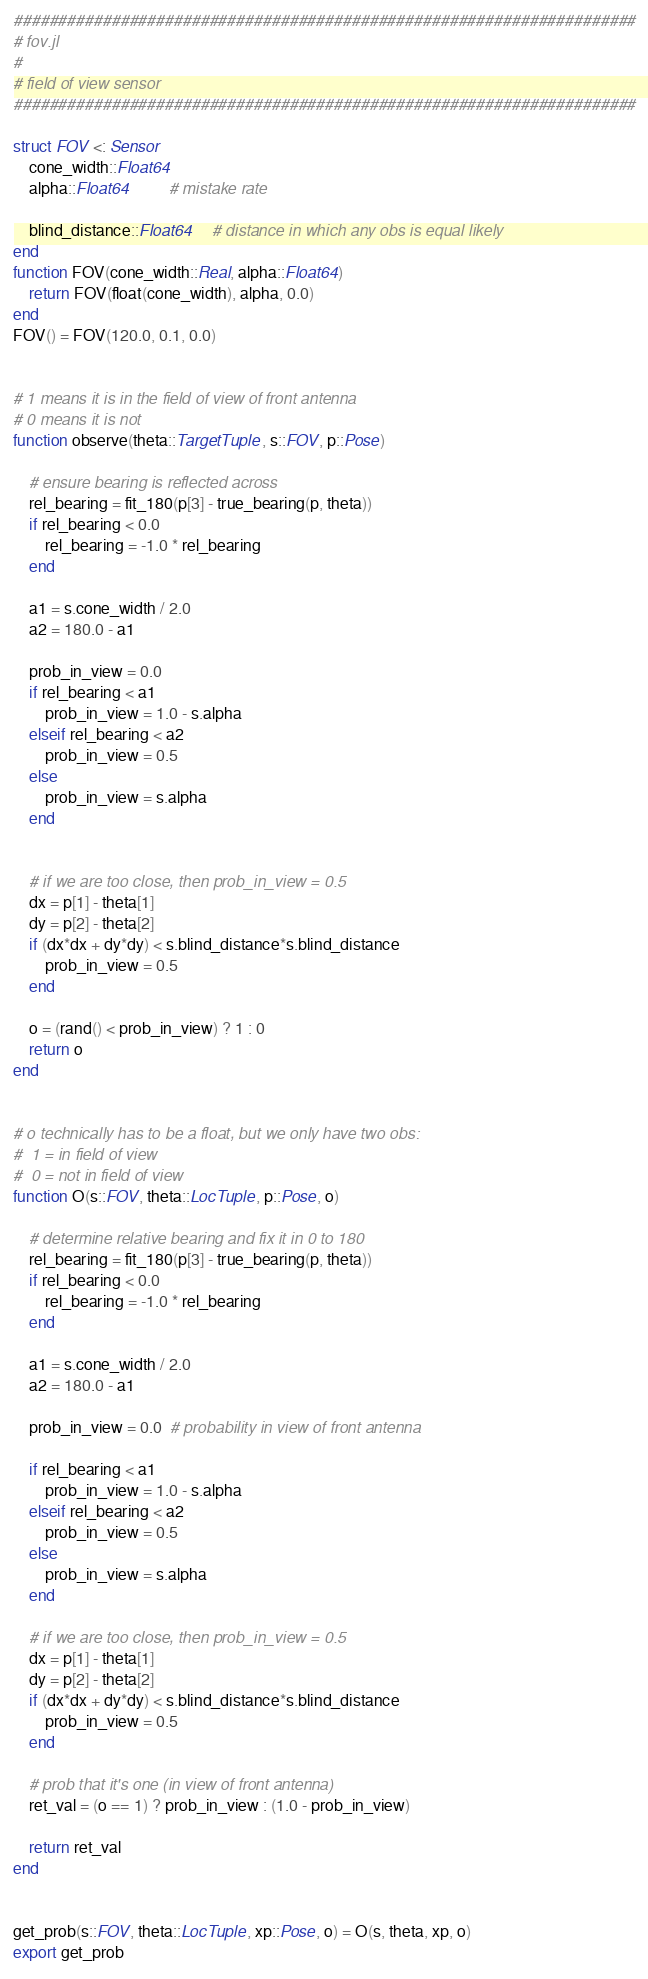<code> <loc_0><loc_0><loc_500><loc_500><_Julia_>######################################################################
# fov.jl
#
# field of view sensor
######################################################################

struct FOV <: Sensor
    cone_width::Float64
    alpha::Float64          # mistake rate

    blind_distance::Float64     # distance in which any obs is equal likely
end
function FOV(cone_width::Real, alpha::Float64)
    return FOV(float(cone_width), alpha, 0.0)
end
FOV() = FOV(120.0, 0.1, 0.0)


# 1 means it is in the field of view of front antenna
# 0 means it is not
function observe(theta::TargetTuple, s::FOV, p::Pose)

    # ensure bearing is reflected across
    rel_bearing = fit_180(p[3] - true_bearing(p, theta))
    if rel_bearing < 0.0
        rel_bearing = -1.0 * rel_bearing
    end

    a1 = s.cone_width / 2.0
    a2 = 180.0 - a1

    prob_in_view = 0.0
    if rel_bearing < a1
        prob_in_view = 1.0 - s.alpha
    elseif rel_bearing < a2
        prob_in_view = 0.5
    else
        prob_in_view = s.alpha
    end


    # if we are too close, then prob_in_view = 0.5
    dx = p[1] - theta[1]
    dy = p[2] - theta[2]
    if (dx*dx + dy*dy) < s.blind_distance*s.blind_distance
        prob_in_view = 0.5
    end

    o = (rand() < prob_in_view) ? 1 : 0
    return o
end


# o technically has to be a float, but we only have two obs:
#  1 = in field of view
#  0 = not in field of view
function O(s::FOV, theta::LocTuple, p::Pose, o)

    # determine relative bearing and fix it in 0 to 180
    rel_bearing = fit_180(p[3] - true_bearing(p, theta))
    if rel_bearing < 0.0
        rel_bearing = -1.0 * rel_bearing
    end

    a1 = s.cone_width / 2.0
    a2 = 180.0 - a1

    prob_in_view = 0.0  # probability in view of front antenna

    if rel_bearing < a1
        prob_in_view = 1.0 - s.alpha
    elseif rel_bearing < a2
        prob_in_view = 0.5
    else
        prob_in_view = s.alpha
    end

    # if we are too close, then prob_in_view = 0.5
    dx = p[1] - theta[1]
    dy = p[2] - theta[2]
    if (dx*dx + dy*dy) < s.blind_distance*s.blind_distance
        prob_in_view = 0.5
    end

    # prob that it's one (in view of front antenna)
    ret_val = (o == 1) ? prob_in_view : (1.0 - prob_in_view)

    return ret_val
end


get_prob(s::FOV, theta::LocTuple, xp::Pose, o) = O(s, theta, xp, o)
export get_prob
</code> 